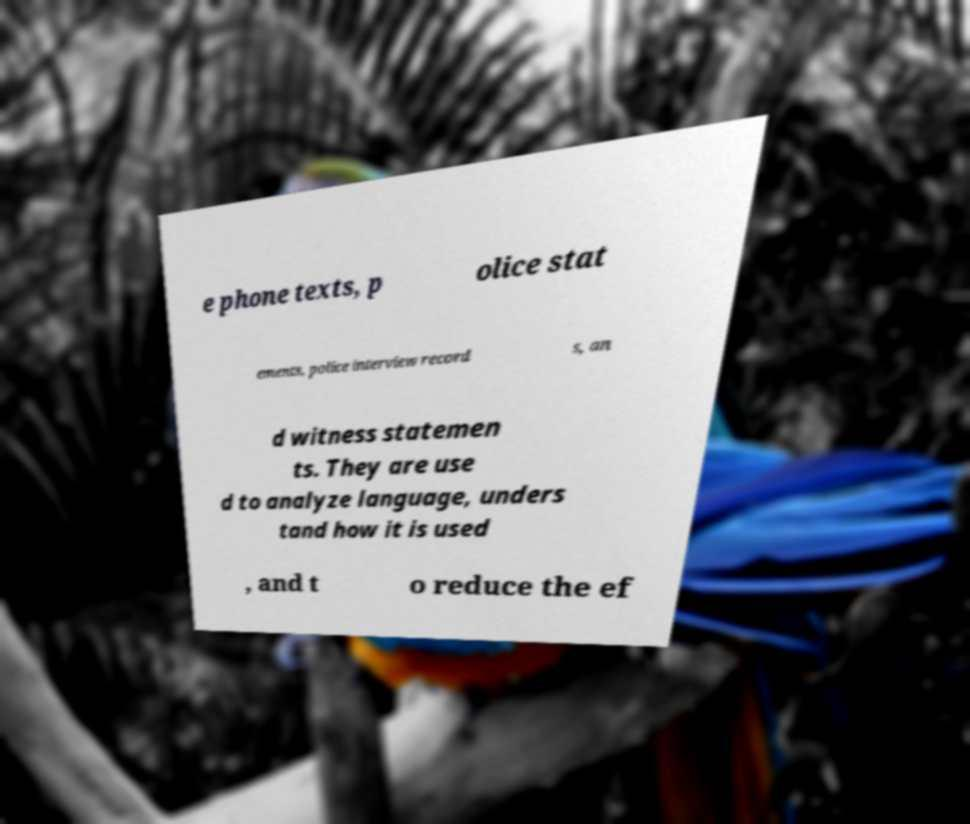What messages or text are displayed in this image? I need them in a readable, typed format. e phone texts, p olice stat ements, police interview record s, an d witness statemen ts. They are use d to analyze language, unders tand how it is used , and t o reduce the ef 